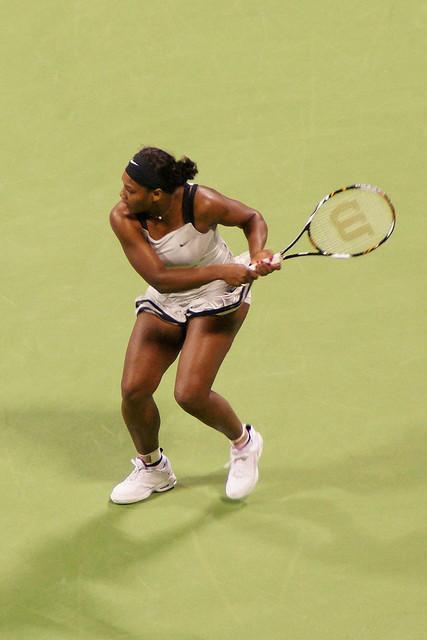How many people are standing?
Give a very brief answer. 1. 